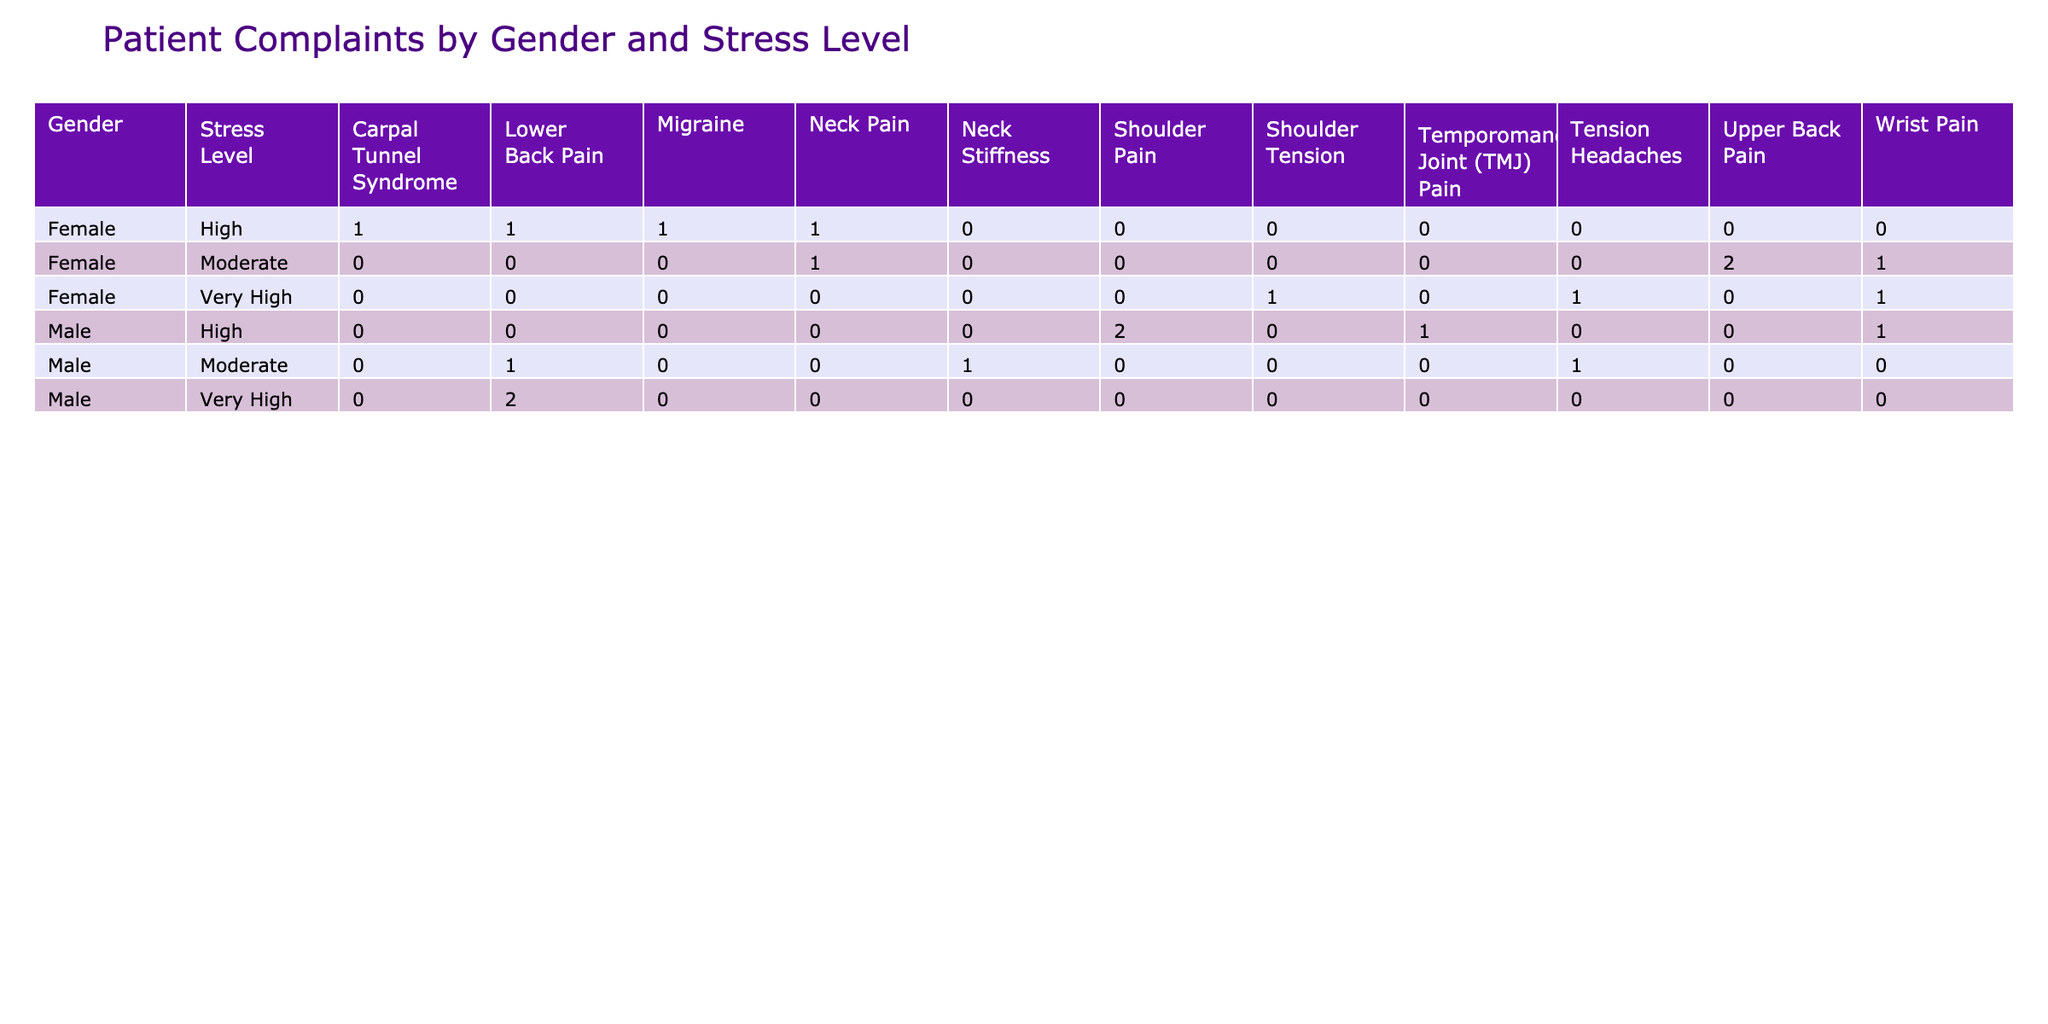What is the most common primary complaint for female patients with a high stress level? To answer this, look at the 'High' stress level row for 'Female' patients in the pivot table. The primary complaint listed is 'Neck Pain' with a count of 5.
Answer: Neck Pain Is there a higher number of male or female patients experiencing tension headaches? By checking the counts for 'Tension Headaches', there are 0 female patients and 1 male patient. Thus, there is a higher number of male patients experiencing this complaint.
Answer: Male What is the total count of shoulder pain complaints among male patients? To find this, check the row for 'Male' and look under the 'Shoulder Pain' column. The total is 3 from the counts found in that row.
Answer: 3 Are there any patients with very high stress levels who do not report neck pain as a primary complaint? By examining the very high stress level rows, patients 3 (Tension Headaches), 9 (Lower Back Pain), 12 (Shoulder Tension), and 17 (Lower Back Pain) all have different primary complaints, indicating yes, there are patients without neck pain as a primary complaint.
Answer: Yes What is the average duration of symptoms for female patients with lower back pain? First, identify female patients with 'Lower Back Pain': Patient 5 (10 weeks) and Patient 14 (14 weeks). Add these durations (10 + 14 = 24 weeks) and divide by the two patients (24 / 2 = 12 weeks) to find the average.
Answer: 12 weeks 